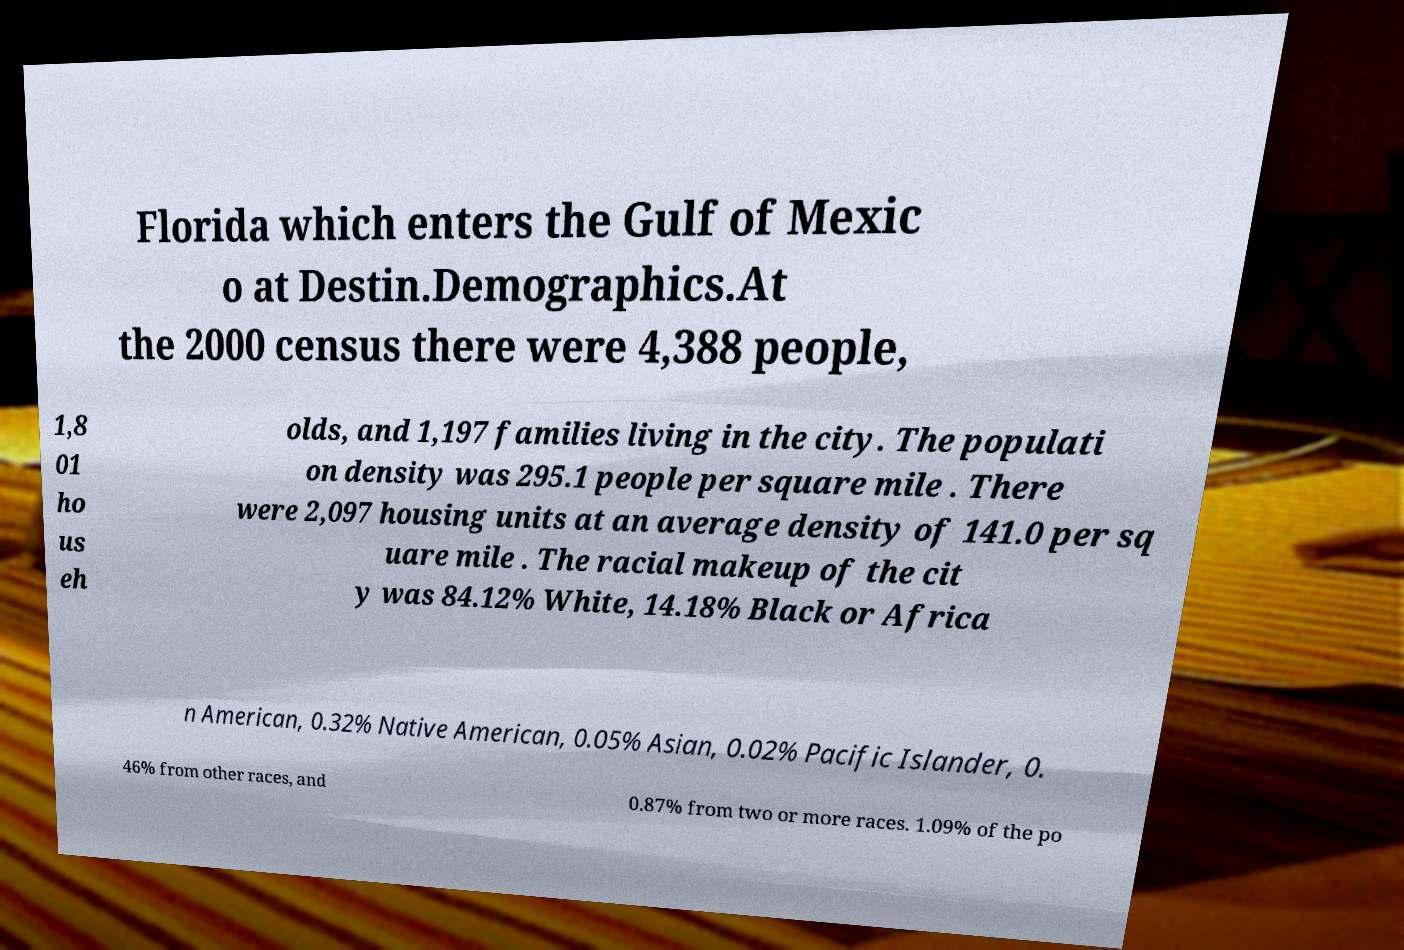Could you assist in decoding the text presented in this image and type it out clearly? Florida which enters the Gulf of Mexic o at Destin.Demographics.At the 2000 census there were 4,388 people, 1,8 01 ho us eh olds, and 1,197 families living in the city. The populati on density was 295.1 people per square mile . There were 2,097 housing units at an average density of 141.0 per sq uare mile . The racial makeup of the cit y was 84.12% White, 14.18% Black or Africa n American, 0.32% Native American, 0.05% Asian, 0.02% Pacific Islander, 0. 46% from other races, and 0.87% from two or more races. 1.09% of the po 